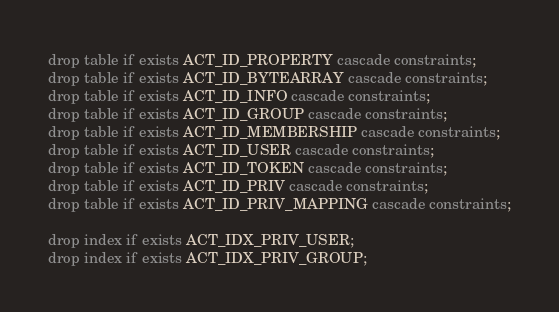Convert code to text. <code><loc_0><loc_0><loc_500><loc_500><_SQL_>drop table if exists ACT_ID_PROPERTY cascade constraints;
drop table if exists ACT_ID_BYTEARRAY cascade constraints;
drop table if exists ACT_ID_INFO cascade constraints;
drop table if exists ACT_ID_GROUP cascade constraints;
drop table if exists ACT_ID_MEMBERSHIP cascade constraints;
drop table if exists ACT_ID_USER cascade constraints;
drop table if exists ACT_ID_TOKEN cascade constraints;
drop table if exists ACT_ID_PRIV cascade constraints;
drop table if exists ACT_ID_PRIV_MAPPING cascade constraints;

drop index if exists ACT_IDX_PRIV_USER;
drop index if exists ACT_IDX_PRIV_GROUP;</code> 